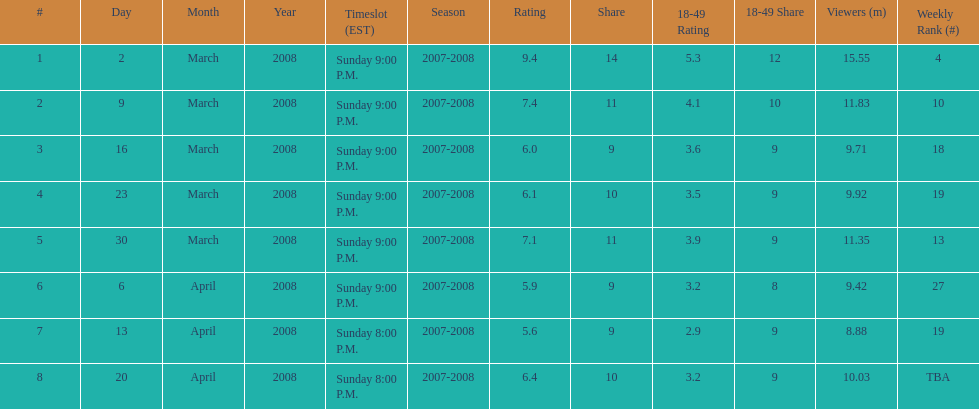How long did the program air for in days? 8. 